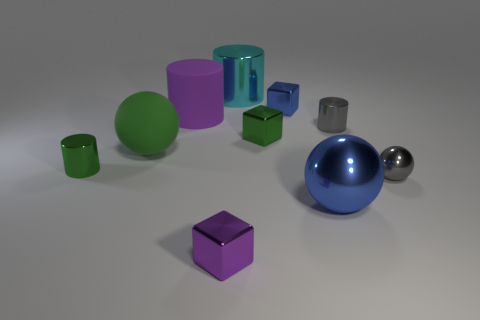There is a matte ball; does it have the same size as the blue object in front of the matte cylinder? Based on the perspective in this image, the matte ball appears to be slightly smaller when compared to the blue glass object in front of the matte cylinder. Size perception can be tricky in images without a common reference point, but visually, the ball seems somewhat smaller. 